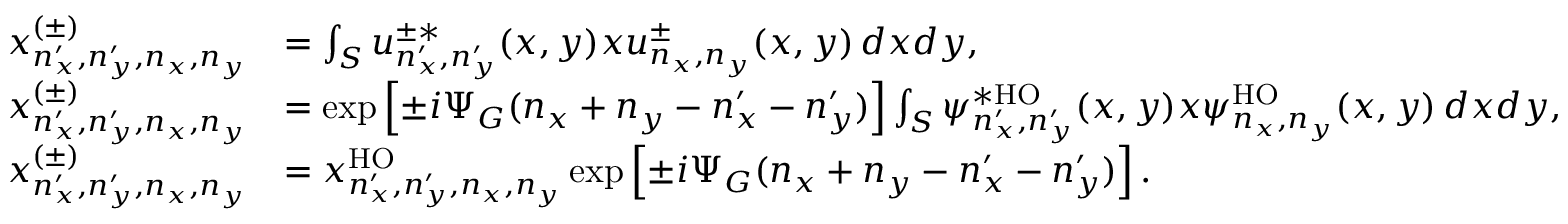Convert formula to latex. <formula><loc_0><loc_0><loc_500><loc_500>\begin{array} { r l } { x _ { n _ { x } ^ { \prime } , n _ { y } ^ { \prime } , n _ { x } , n _ { y } } ^ { ( \pm ) } } & { = \int _ { S } u _ { n _ { x } ^ { \prime } , n _ { y } ^ { \prime } } ^ { \pm * } ( x , y ) x u _ { n _ { x } , n _ { y } } ^ { \pm } ( x , y ) \, d x d y , } \\ { x _ { n _ { x } ^ { \prime } , n _ { y } ^ { \prime } , n _ { x } , n _ { y } } ^ { ( \pm ) } } & { = \exp \left [ \pm i \Psi _ { G } ( n _ { x } + n _ { y } - n _ { x } ^ { \prime } - n _ { y } ^ { \prime } ) \right ] \int _ { S } \psi _ { n _ { x } ^ { \prime } , n _ { y } ^ { \prime } } ^ { * H O } ( x , y ) x \psi _ { n _ { x } , n _ { y } } ^ { H O } ( x , y ) \, d x d y , } \\ { x _ { n _ { x } ^ { \prime } , n _ { y } ^ { \prime } , n _ { x } , n _ { y } } ^ { ( \pm ) } } & { = x _ { n _ { x } ^ { \prime } , n _ { y } ^ { \prime } , n _ { x } , n _ { y } } ^ { H O } \exp \left [ \pm i \Psi _ { G } ( n _ { x } + n _ { y } - n _ { x } ^ { \prime } - n _ { y } ^ { \prime } ) \right ] . } \end{array}</formula> 